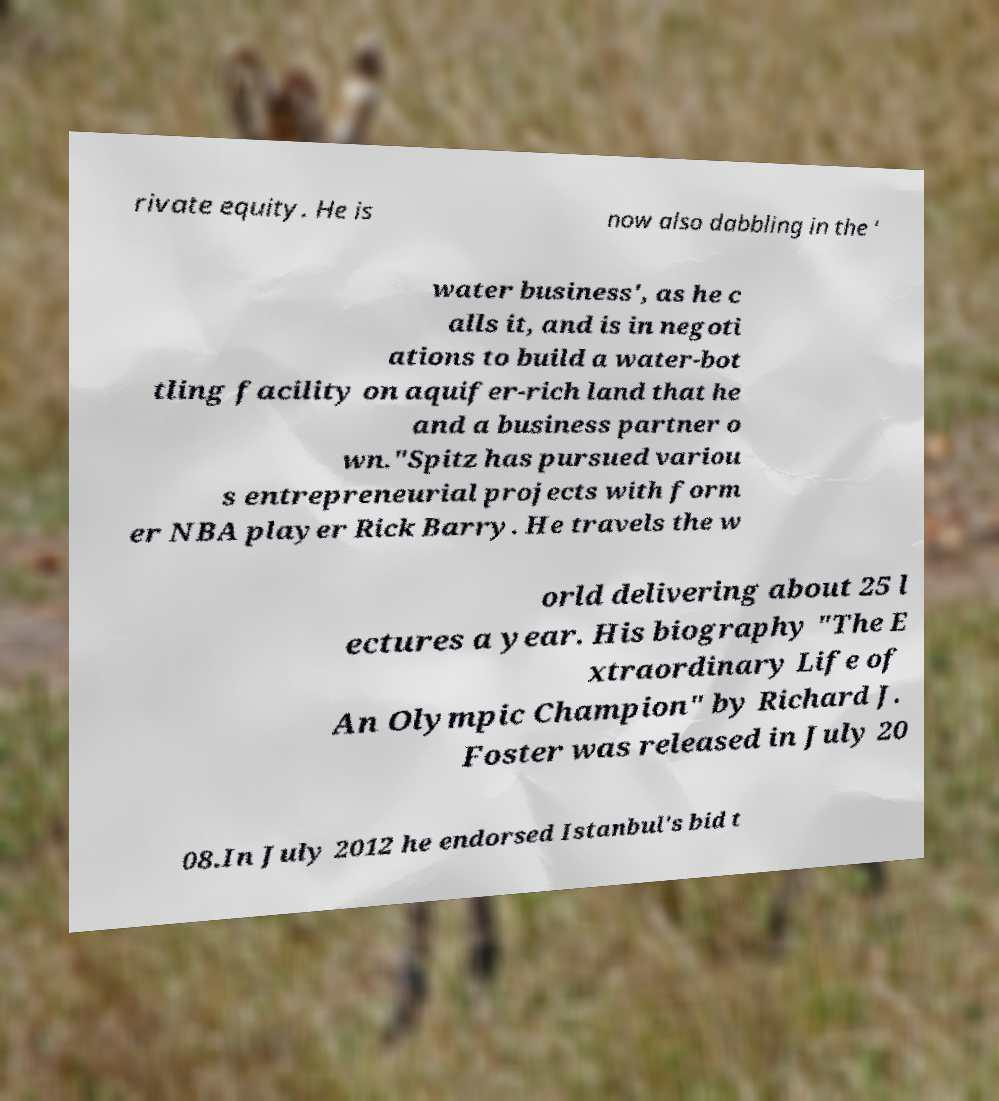Could you assist in decoding the text presented in this image and type it out clearly? rivate equity. He is now also dabbling in the ' water business', as he c alls it, and is in negoti ations to build a water-bot tling facility on aquifer-rich land that he and a business partner o wn."Spitz has pursued variou s entrepreneurial projects with form er NBA player Rick Barry. He travels the w orld delivering about 25 l ectures a year. His biography "The E xtraordinary Life of An Olympic Champion" by Richard J. Foster was released in July 20 08.In July 2012 he endorsed Istanbul's bid t 